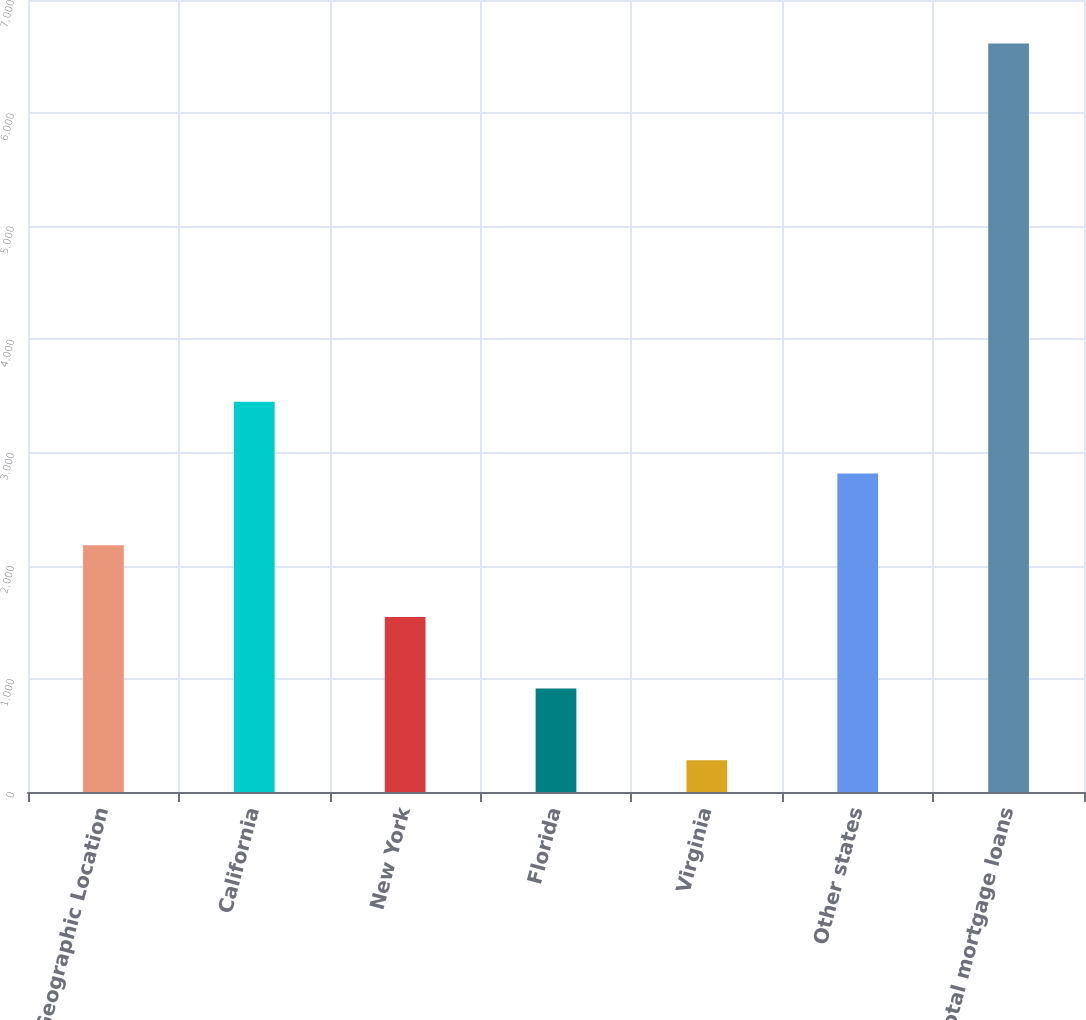Convert chart. <chart><loc_0><loc_0><loc_500><loc_500><bar_chart><fcel>Geographic Location<fcel>California<fcel>New York<fcel>Florida<fcel>Virginia<fcel>Other states<fcel>Total mortgage loans<nl><fcel>2181.3<fcel>3448.3<fcel>1547.8<fcel>914.3<fcel>280.8<fcel>2814.8<fcel>6615.8<nl></chart> 